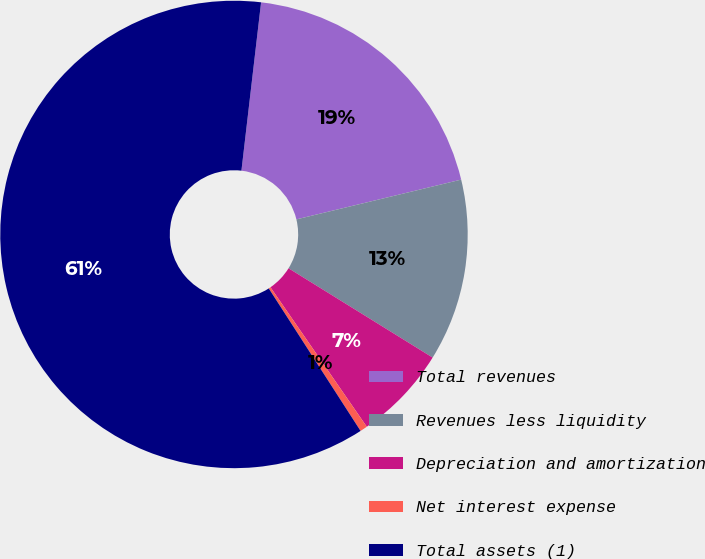Convert chart. <chart><loc_0><loc_0><loc_500><loc_500><pie_chart><fcel>Total revenues<fcel>Revenues less liquidity<fcel>Depreciation and amortization<fcel>Net interest expense<fcel>Total assets (1)<nl><fcel>19.38%<fcel>12.6%<fcel>6.55%<fcel>0.51%<fcel>60.96%<nl></chart> 